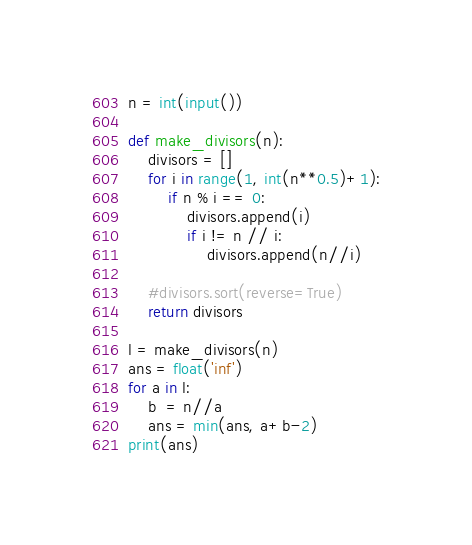Convert code to text. <code><loc_0><loc_0><loc_500><loc_500><_Python_>n = int(input())

def make_divisors(n):
    divisors = []
    for i in range(1, int(n**0.5)+1):
        if n % i == 0:
            divisors.append(i)
            if i != n // i:
                divisors.append(n//i)

    #divisors.sort(reverse=True)
    return divisors

l = make_divisors(n)
ans = float('inf')
for a in l:
    b  = n//a
    ans = min(ans, a+b-2)
print(ans)</code> 